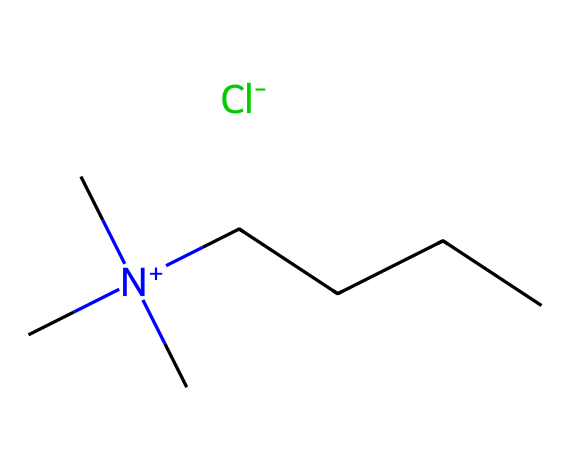What is the total number of carbon atoms in the ionic liquid? By examining the chemical structure represented by the SMILES notation, we can count the carbon atoms. The notation includes four methyl groups (from the [N+](C)(C)(C) part) and a straight-chain alkyl group (CCCC) containing four additional carbon atoms. Thus, there are a total of 4 + 4 = 8 carbon atoms.
Answer: eight What is the type of cation in this ionic liquid? The structure indicates a quaternary ammonium cation due to the presence of a positively charged nitrogen atom bonded to three methyl groups and one alkyl chain. This defines it as a type of ionic liquid with a specific quaternary structure.
Answer: quaternary ammonium What is the anion associated with this ionic liquid? The compound mentions [Cl-] as its counter ion, indicating that chlorine serves as the anion paired with the cationic part, essential for forming the ionic liquid structure.
Answer: chloride What is the net charge of the ionic liquid? By analyzing the structure, the nitrogen cation has a positive charge ([N+]), while the chloride anion has a negative charge ([Cl-]). Summing these charges leads to a net charge of zero, which defines it as a neutral ionic liquid overall.
Answer: zero How many nitrogen atoms are present in the ionic liquid? In the provided SMILES representation, there is a single nitrogen atom present, which is part of the quaternary ammonium cation structure. Therefore, it can be confirmed that there is one nitrogen atom within this particular ionic liquid composition.
Answer: one What property of ionic liquids is likely enhanced by the presence of a long-chain alkyl group? The long-chain alkyl structure typically contributes to the hydrophobic character of ionic liquids, which can affect their solubility and stability in various environments, making them useful in applications like inks, similar to blood-red ink.
Answer: hydrophobicity 